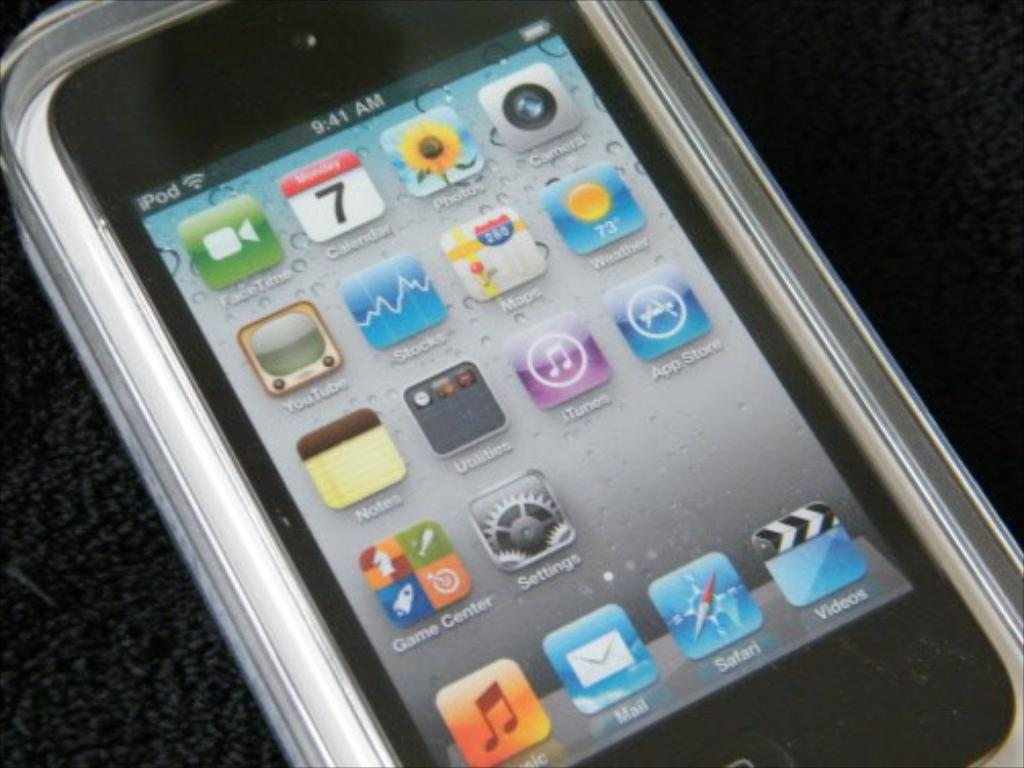<image>
Provide a brief description of the given image. An Ipod display screen with Safari icon visible. 